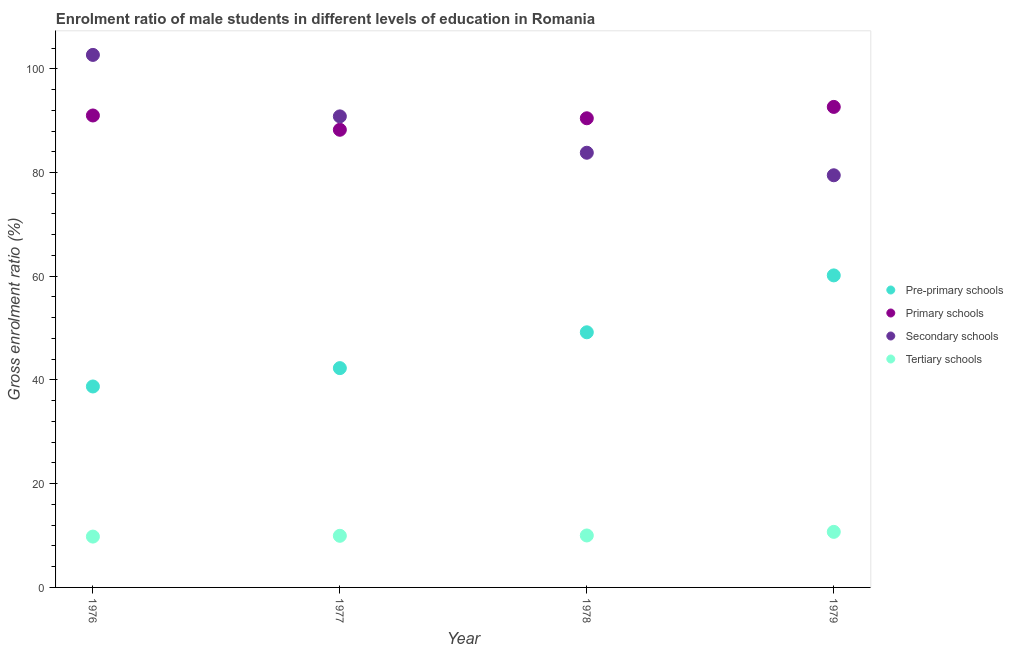How many different coloured dotlines are there?
Give a very brief answer. 4. Is the number of dotlines equal to the number of legend labels?
Provide a succinct answer. Yes. What is the gross enrolment ratio(female) in pre-primary schools in 1979?
Offer a terse response. 60.16. Across all years, what is the maximum gross enrolment ratio(female) in pre-primary schools?
Offer a terse response. 60.16. Across all years, what is the minimum gross enrolment ratio(female) in pre-primary schools?
Give a very brief answer. 38.74. In which year was the gross enrolment ratio(female) in tertiary schools maximum?
Provide a short and direct response. 1979. In which year was the gross enrolment ratio(female) in tertiary schools minimum?
Your response must be concise. 1976. What is the total gross enrolment ratio(female) in tertiary schools in the graph?
Keep it short and to the point. 40.49. What is the difference between the gross enrolment ratio(female) in tertiary schools in 1976 and that in 1978?
Provide a succinct answer. -0.22. What is the difference between the gross enrolment ratio(female) in primary schools in 1979 and the gross enrolment ratio(female) in tertiary schools in 1978?
Keep it short and to the point. 82.63. What is the average gross enrolment ratio(female) in pre-primary schools per year?
Your answer should be very brief. 47.6. In the year 1978, what is the difference between the gross enrolment ratio(female) in secondary schools and gross enrolment ratio(female) in primary schools?
Keep it short and to the point. -6.64. What is the ratio of the gross enrolment ratio(female) in secondary schools in 1978 to that in 1979?
Ensure brevity in your answer.  1.05. Is the gross enrolment ratio(female) in tertiary schools in 1977 less than that in 1978?
Keep it short and to the point. Yes. Is the difference between the gross enrolment ratio(female) in secondary schools in 1976 and 1977 greater than the difference between the gross enrolment ratio(female) in tertiary schools in 1976 and 1977?
Provide a succinct answer. Yes. What is the difference between the highest and the second highest gross enrolment ratio(female) in primary schools?
Make the answer very short. 1.65. What is the difference between the highest and the lowest gross enrolment ratio(female) in secondary schools?
Your answer should be very brief. 23.21. In how many years, is the gross enrolment ratio(female) in primary schools greater than the average gross enrolment ratio(female) in primary schools taken over all years?
Your response must be concise. 2. Is it the case that in every year, the sum of the gross enrolment ratio(female) in pre-primary schools and gross enrolment ratio(female) in primary schools is greater than the sum of gross enrolment ratio(female) in tertiary schools and gross enrolment ratio(female) in secondary schools?
Provide a succinct answer. Yes. Does the gross enrolment ratio(female) in pre-primary schools monotonically increase over the years?
Give a very brief answer. Yes. Is the gross enrolment ratio(female) in secondary schools strictly greater than the gross enrolment ratio(female) in tertiary schools over the years?
Your response must be concise. Yes. Is the gross enrolment ratio(female) in tertiary schools strictly less than the gross enrolment ratio(female) in primary schools over the years?
Your response must be concise. Yes. How many dotlines are there?
Your answer should be compact. 4. Does the graph contain any zero values?
Your answer should be very brief. No. Does the graph contain grids?
Offer a very short reply. No. Where does the legend appear in the graph?
Offer a terse response. Center right. How many legend labels are there?
Provide a succinct answer. 4. How are the legend labels stacked?
Your answer should be very brief. Vertical. What is the title of the graph?
Keep it short and to the point. Enrolment ratio of male students in different levels of education in Romania. Does "Fourth 20% of population" appear as one of the legend labels in the graph?
Your answer should be very brief. No. What is the label or title of the Y-axis?
Keep it short and to the point. Gross enrolment ratio (%). What is the Gross enrolment ratio (%) of Pre-primary schools in 1976?
Provide a succinct answer. 38.74. What is the Gross enrolment ratio (%) in Primary schools in 1976?
Make the answer very short. 91. What is the Gross enrolment ratio (%) in Secondary schools in 1976?
Your answer should be very brief. 102.67. What is the Gross enrolment ratio (%) in Tertiary schools in 1976?
Provide a short and direct response. 9.8. What is the Gross enrolment ratio (%) of Pre-primary schools in 1977?
Offer a very short reply. 42.28. What is the Gross enrolment ratio (%) of Primary schools in 1977?
Give a very brief answer. 88.24. What is the Gross enrolment ratio (%) of Secondary schools in 1977?
Give a very brief answer. 90.82. What is the Gross enrolment ratio (%) in Tertiary schools in 1977?
Your answer should be compact. 9.95. What is the Gross enrolment ratio (%) of Pre-primary schools in 1978?
Make the answer very short. 49.19. What is the Gross enrolment ratio (%) in Primary schools in 1978?
Your answer should be very brief. 90.46. What is the Gross enrolment ratio (%) of Secondary schools in 1978?
Your answer should be compact. 83.81. What is the Gross enrolment ratio (%) in Tertiary schools in 1978?
Offer a terse response. 10.02. What is the Gross enrolment ratio (%) of Pre-primary schools in 1979?
Your answer should be compact. 60.16. What is the Gross enrolment ratio (%) in Primary schools in 1979?
Your response must be concise. 92.65. What is the Gross enrolment ratio (%) in Secondary schools in 1979?
Your answer should be very brief. 79.47. What is the Gross enrolment ratio (%) of Tertiary schools in 1979?
Provide a succinct answer. 10.71. Across all years, what is the maximum Gross enrolment ratio (%) in Pre-primary schools?
Offer a very short reply. 60.16. Across all years, what is the maximum Gross enrolment ratio (%) in Primary schools?
Your response must be concise. 92.65. Across all years, what is the maximum Gross enrolment ratio (%) in Secondary schools?
Your answer should be compact. 102.67. Across all years, what is the maximum Gross enrolment ratio (%) in Tertiary schools?
Provide a succinct answer. 10.71. Across all years, what is the minimum Gross enrolment ratio (%) of Pre-primary schools?
Your response must be concise. 38.74. Across all years, what is the minimum Gross enrolment ratio (%) of Primary schools?
Keep it short and to the point. 88.24. Across all years, what is the minimum Gross enrolment ratio (%) in Secondary schools?
Your answer should be compact. 79.47. Across all years, what is the minimum Gross enrolment ratio (%) of Tertiary schools?
Provide a short and direct response. 9.8. What is the total Gross enrolment ratio (%) of Pre-primary schools in the graph?
Offer a very short reply. 190.38. What is the total Gross enrolment ratio (%) of Primary schools in the graph?
Your response must be concise. 362.34. What is the total Gross enrolment ratio (%) in Secondary schools in the graph?
Provide a succinct answer. 356.78. What is the total Gross enrolment ratio (%) of Tertiary schools in the graph?
Give a very brief answer. 40.49. What is the difference between the Gross enrolment ratio (%) in Pre-primary schools in 1976 and that in 1977?
Provide a succinct answer. -3.54. What is the difference between the Gross enrolment ratio (%) of Primary schools in 1976 and that in 1977?
Make the answer very short. 2.76. What is the difference between the Gross enrolment ratio (%) in Secondary schools in 1976 and that in 1977?
Make the answer very short. 11.85. What is the difference between the Gross enrolment ratio (%) in Tertiary schools in 1976 and that in 1977?
Your answer should be compact. -0.15. What is the difference between the Gross enrolment ratio (%) of Pre-primary schools in 1976 and that in 1978?
Offer a very short reply. -10.45. What is the difference between the Gross enrolment ratio (%) in Primary schools in 1976 and that in 1978?
Give a very brief answer. 0.54. What is the difference between the Gross enrolment ratio (%) of Secondary schools in 1976 and that in 1978?
Give a very brief answer. 18.86. What is the difference between the Gross enrolment ratio (%) of Tertiary schools in 1976 and that in 1978?
Make the answer very short. -0.22. What is the difference between the Gross enrolment ratio (%) of Pre-primary schools in 1976 and that in 1979?
Your answer should be very brief. -21.42. What is the difference between the Gross enrolment ratio (%) of Primary schools in 1976 and that in 1979?
Ensure brevity in your answer.  -1.65. What is the difference between the Gross enrolment ratio (%) in Secondary schools in 1976 and that in 1979?
Ensure brevity in your answer.  23.21. What is the difference between the Gross enrolment ratio (%) in Tertiary schools in 1976 and that in 1979?
Ensure brevity in your answer.  -0.91. What is the difference between the Gross enrolment ratio (%) of Pre-primary schools in 1977 and that in 1978?
Make the answer very short. -6.91. What is the difference between the Gross enrolment ratio (%) in Primary schools in 1977 and that in 1978?
Your answer should be very brief. -2.22. What is the difference between the Gross enrolment ratio (%) of Secondary schools in 1977 and that in 1978?
Make the answer very short. 7.01. What is the difference between the Gross enrolment ratio (%) of Tertiary schools in 1977 and that in 1978?
Your answer should be very brief. -0.06. What is the difference between the Gross enrolment ratio (%) in Pre-primary schools in 1977 and that in 1979?
Your answer should be very brief. -17.88. What is the difference between the Gross enrolment ratio (%) in Primary schools in 1977 and that in 1979?
Offer a terse response. -4.41. What is the difference between the Gross enrolment ratio (%) in Secondary schools in 1977 and that in 1979?
Provide a succinct answer. 11.36. What is the difference between the Gross enrolment ratio (%) in Tertiary schools in 1977 and that in 1979?
Your answer should be compact. -0.76. What is the difference between the Gross enrolment ratio (%) of Pre-primary schools in 1978 and that in 1979?
Offer a terse response. -10.97. What is the difference between the Gross enrolment ratio (%) in Primary schools in 1978 and that in 1979?
Ensure brevity in your answer.  -2.19. What is the difference between the Gross enrolment ratio (%) in Secondary schools in 1978 and that in 1979?
Your answer should be compact. 4.35. What is the difference between the Gross enrolment ratio (%) in Tertiary schools in 1978 and that in 1979?
Ensure brevity in your answer.  -0.7. What is the difference between the Gross enrolment ratio (%) of Pre-primary schools in 1976 and the Gross enrolment ratio (%) of Primary schools in 1977?
Offer a very short reply. -49.5. What is the difference between the Gross enrolment ratio (%) in Pre-primary schools in 1976 and the Gross enrolment ratio (%) in Secondary schools in 1977?
Offer a terse response. -52.08. What is the difference between the Gross enrolment ratio (%) of Pre-primary schools in 1976 and the Gross enrolment ratio (%) of Tertiary schools in 1977?
Ensure brevity in your answer.  28.79. What is the difference between the Gross enrolment ratio (%) in Primary schools in 1976 and the Gross enrolment ratio (%) in Secondary schools in 1977?
Your response must be concise. 0.17. What is the difference between the Gross enrolment ratio (%) in Primary schools in 1976 and the Gross enrolment ratio (%) in Tertiary schools in 1977?
Provide a succinct answer. 81.04. What is the difference between the Gross enrolment ratio (%) in Secondary schools in 1976 and the Gross enrolment ratio (%) in Tertiary schools in 1977?
Offer a very short reply. 92.72. What is the difference between the Gross enrolment ratio (%) in Pre-primary schools in 1976 and the Gross enrolment ratio (%) in Primary schools in 1978?
Keep it short and to the point. -51.71. What is the difference between the Gross enrolment ratio (%) in Pre-primary schools in 1976 and the Gross enrolment ratio (%) in Secondary schools in 1978?
Keep it short and to the point. -45.07. What is the difference between the Gross enrolment ratio (%) in Pre-primary schools in 1976 and the Gross enrolment ratio (%) in Tertiary schools in 1978?
Provide a succinct answer. 28.73. What is the difference between the Gross enrolment ratio (%) in Primary schools in 1976 and the Gross enrolment ratio (%) in Secondary schools in 1978?
Offer a very short reply. 7.18. What is the difference between the Gross enrolment ratio (%) of Primary schools in 1976 and the Gross enrolment ratio (%) of Tertiary schools in 1978?
Provide a succinct answer. 80.98. What is the difference between the Gross enrolment ratio (%) in Secondary schools in 1976 and the Gross enrolment ratio (%) in Tertiary schools in 1978?
Provide a short and direct response. 92.66. What is the difference between the Gross enrolment ratio (%) in Pre-primary schools in 1976 and the Gross enrolment ratio (%) in Primary schools in 1979?
Offer a very short reply. -53.9. What is the difference between the Gross enrolment ratio (%) in Pre-primary schools in 1976 and the Gross enrolment ratio (%) in Secondary schools in 1979?
Your answer should be compact. -40.72. What is the difference between the Gross enrolment ratio (%) of Pre-primary schools in 1976 and the Gross enrolment ratio (%) of Tertiary schools in 1979?
Keep it short and to the point. 28.03. What is the difference between the Gross enrolment ratio (%) in Primary schools in 1976 and the Gross enrolment ratio (%) in Secondary schools in 1979?
Offer a terse response. 11.53. What is the difference between the Gross enrolment ratio (%) in Primary schools in 1976 and the Gross enrolment ratio (%) in Tertiary schools in 1979?
Offer a terse response. 80.28. What is the difference between the Gross enrolment ratio (%) in Secondary schools in 1976 and the Gross enrolment ratio (%) in Tertiary schools in 1979?
Provide a short and direct response. 91.96. What is the difference between the Gross enrolment ratio (%) in Pre-primary schools in 1977 and the Gross enrolment ratio (%) in Primary schools in 1978?
Your answer should be very brief. -48.17. What is the difference between the Gross enrolment ratio (%) in Pre-primary schools in 1977 and the Gross enrolment ratio (%) in Secondary schools in 1978?
Offer a very short reply. -41.53. What is the difference between the Gross enrolment ratio (%) in Pre-primary schools in 1977 and the Gross enrolment ratio (%) in Tertiary schools in 1978?
Your answer should be compact. 32.27. What is the difference between the Gross enrolment ratio (%) of Primary schools in 1977 and the Gross enrolment ratio (%) of Secondary schools in 1978?
Provide a short and direct response. 4.43. What is the difference between the Gross enrolment ratio (%) in Primary schools in 1977 and the Gross enrolment ratio (%) in Tertiary schools in 1978?
Make the answer very short. 78.22. What is the difference between the Gross enrolment ratio (%) of Secondary schools in 1977 and the Gross enrolment ratio (%) of Tertiary schools in 1978?
Your response must be concise. 80.81. What is the difference between the Gross enrolment ratio (%) of Pre-primary schools in 1977 and the Gross enrolment ratio (%) of Primary schools in 1979?
Ensure brevity in your answer.  -50.36. What is the difference between the Gross enrolment ratio (%) in Pre-primary schools in 1977 and the Gross enrolment ratio (%) in Secondary schools in 1979?
Provide a succinct answer. -37.18. What is the difference between the Gross enrolment ratio (%) in Pre-primary schools in 1977 and the Gross enrolment ratio (%) in Tertiary schools in 1979?
Give a very brief answer. 31.57. What is the difference between the Gross enrolment ratio (%) in Primary schools in 1977 and the Gross enrolment ratio (%) in Secondary schools in 1979?
Your response must be concise. 8.77. What is the difference between the Gross enrolment ratio (%) of Primary schools in 1977 and the Gross enrolment ratio (%) of Tertiary schools in 1979?
Provide a succinct answer. 77.53. What is the difference between the Gross enrolment ratio (%) of Secondary schools in 1977 and the Gross enrolment ratio (%) of Tertiary schools in 1979?
Offer a terse response. 80.11. What is the difference between the Gross enrolment ratio (%) in Pre-primary schools in 1978 and the Gross enrolment ratio (%) in Primary schools in 1979?
Offer a terse response. -43.46. What is the difference between the Gross enrolment ratio (%) of Pre-primary schools in 1978 and the Gross enrolment ratio (%) of Secondary schools in 1979?
Your answer should be very brief. -30.27. What is the difference between the Gross enrolment ratio (%) in Pre-primary schools in 1978 and the Gross enrolment ratio (%) in Tertiary schools in 1979?
Provide a short and direct response. 38.48. What is the difference between the Gross enrolment ratio (%) of Primary schools in 1978 and the Gross enrolment ratio (%) of Secondary schools in 1979?
Provide a short and direct response. 10.99. What is the difference between the Gross enrolment ratio (%) of Primary schools in 1978 and the Gross enrolment ratio (%) of Tertiary schools in 1979?
Offer a very short reply. 79.74. What is the difference between the Gross enrolment ratio (%) in Secondary schools in 1978 and the Gross enrolment ratio (%) in Tertiary schools in 1979?
Give a very brief answer. 73.1. What is the average Gross enrolment ratio (%) in Pre-primary schools per year?
Keep it short and to the point. 47.6. What is the average Gross enrolment ratio (%) of Primary schools per year?
Your answer should be very brief. 90.58. What is the average Gross enrolment ratio (%) in Secondary schools per year?
Your answer should be very brief. 89.19. What is the average Gross enrolment ratio (%) of Tertiary schools per year?
Offer a very short reply. 10.12. In the year 1976, what is the difference between the Gross enrolment ratio (%) of Pre-primary schools and Gross enrolment ratio (%) of Primary schools?
Provide a short and direct response. -52.25. In the year 1976, what is the difference between the Gross enrolment ratio (%) of Pre-primary schools and Gross enrolment ratio (%) of Secondary schools?
Offer a terse response. -63.93. In the year 1976, what is the difference between the Gross enrolment ratio (%) of Pre-primary schools and Gross enrolment ratio (%) of Tertiary schools?
Offer a terse response. 28.94. In the year 1976, what is the difference between the Gross enrolment ratio (%) in Primary schools and Gross enrolment ratio (%) in Secondary schools?
Make the answer very short. -11.68. In the year 1976, what is the difference between the Gross enrolment ratio (%) of Primary schools and Gross enrolment ratio (%) of Tertiary schools?
Offer a terse response. 81.19. In the year 1976, what is the difference between the Gross enrolment ratio (%) of Secondary schools and Gross enrolment ratio (%) of Tertiary schools?
Keep it short and to the point. 92.87. In the year 1977, what is the difference between the Gross enrolment ratio (%) in Pre-primary schools and Gross enrolment ratio (%) in Primary schools?
Keep it short and to the point. -45.96. In the year 1977, what is the difference between the Gross enrolment ratio (%) in Pre-primary schools and Gross enrolment ratio (%) in Secondary schools?
Ensure brevity in your answer.  -48.54. In the year 1977, what is the difference between the Gross enrolment ratio (%) in Pre-primary schools and Gross enrolment ratio (%) in Tertiary schools?
Offer a terse response. 32.33. In the year 1977, what is the difference between the Gross enrolment ratio (%) in Primary schools and Gross enrolment ratio (%) in Secondary schools?
Your response must be concise. -2.58. In the year 1977, what is the difference between the Gross enrolment ratio (%) of Primary schools and Gross enrolment ratio (%) of Tertiary schools?
Your answer should be very brief. 78.29. In the year 1977, what is the difference between the Gross enrolment ratio (%) in Secondary schools and Gross enrolment ratio (%) in Tertiary schools?
Ensure brevity in your answer.  80.87. In the year 1978, what is the difference between the Gross enrolment ratio (%) of Pre-primary schools and Gross enrolment ratio (%) of Primary schools?
Your answer should be very brief. -41.26. In the year 1978, what is the difference between the Gross enrolment ratio (%) of Pre-primary schools and Gross enrolment ratio (%) of Secondary schools?
Offer a very short reply. -34.62. In the year 1978, what is the difference between the Gross enrolment ratio (%) in Pre-primary schools and Gross enrolment ratio (%) in Tertiary schools?
Your answer should be compact. 39.17. In the year 1978, what is the difference between the Gross enrolment ratio (%) of Primary schools and Gross enrolment ratio (%) of Secondary schools?
Your answer should be compact. 6.64. In the year 1978, what is the difference between the Gross enrolment ratio (%) in Primary schools and Gross enrolment ratio (%) in Tertiary schools?
Your response must be concise. 80.44. In the year 1978, what is the difference between the Gross enrolment ratio (%) of Secondary schools and Gross enrolment ratio (%) of Tertiary schools?
Offer a terse response. 73.79. In the year 1979, what is the difference between the Gross enrolment ratio (%) in Pre-primary schools and Gross enrolment ratio (%) in Primary schools?
Ensure brevity in your answer.  -32.49. In the year 1979, what is the difference between the Gross enrolment ratio (%) of Pre-primary schools and Gross enrolment ratio (%) of Secondary schools?
Offer a very short reply. -19.3. In the year 1979, what is the difference between the Gross enrolment ratio (%) of Pre-primary schools and Gross enrolment ratio (%) of Tertiary schools?
Provide a short and direct response. 49.45. In the year 1979, what is the difference between the Gross enrolment ratio (%) of Primary schools and Gross enrolment ratio (%) of Secondary schools?
Provide a succinct answer. 13.18. In the year 1979, what is the difference between the Gross enrolment ratio (%) of Primary schools and Gross enrolment ratio (%) of Tertiary schools?
Offer a very short reply. 81.94. In the year 1979, what is the difference between the Gross enrolment ratio (%) in Secondary schools and Gross enrolment ratio (%) in Tertiary schools?
Offer a terse response. 68.75. What is the ratio of the Gross enrolment ratio (%) of Pre-primary schools in 1976 to that in 1977?
Offer a terse response. 0.92. What is the ratio of the Gross enrolment ratio (%) in Primary schools in 1976 to that in 1977?
Keep it short and to the point. 1.03. What is the ratio of the Gross enrolment ratio (%) of Secondary schools in 1976 to that in 1977?
Your answer should be very brief. 1.13. What is the ratio of the Gross enrolment ratio (%) in Tertiary schools in 1976 to that in 1977?
Your response must be concise. 0.98. What is the ratio of the Gross enrolment ratio (%) in Pre-primary schools in 1976 to that in 1978?
Provide a short and direct response. 0.79. What is the ratio of the Gross enrolment ratio (%) in Secondary schools in 1976 to that in 1978?
Give a very brief answer. 1.23. What is the ratio of the Gross enrolment ratio (%) in Tertiary schools in 1976 to that in 1978?
Offer a very short reply. 0.98. What is the ratio of the Gross enrolment ratio (%) of Pre-primary schools in 1976 to that in 1979?
Your answer should be compact. 0.64. What is the ratio of the Gross enrolment ratio (%) of Primary schools in 1976 to that in 1979?
Give a very brief answer. 0.98. What is the ratio of the Gross enrolment ratio (%) in Secondary schools in 1976 to that in 1979?
Provide a succinct answer. 1.29. What is the ratio of the Gross enrolment ratio (%) of Tertiary schools in 1976 to that in 1979?
Your response must be concise. 0.92. What is the ratio of the Gross enrolment ratio (%) of Pre-primary schools in 1977 to that in 1978?
Provide a succinct answer. 0.86. What is the ratio of the Gross enrolment ratio (%) in Primary schools in 1977 to that in 1978?
Offer a very short reply. 0.98. What is the ratio of the Gross enrolment ratio (%) of Secondary schools in 1977 to that in 1978?
Your response must be concise. 1.08. What is the ratio of the Gross enrolment ratio (%) in Pre-primary schools in 1977 to that in 1979?
Make the answer very short. 0.7. What is the ratio of the Gross enrolment ratio (%) in Tertiary schools in 1977 to that in 1979?
Your response must be concise. 0.93. What is the ratio of the Gross enrolment ratio (%) of Pre-primary schools in 1978 to that in 1979?
Your response must be concise. 0.82. What is the ratio of the Gross enrolment ratio (%) in Primary schools in 1978 to that in 1979?
Provide a succinct answer. 0.98. What is the ratio of the Gross enrolment ratio (%) in Secondary schools in 1978 to that in 1979?
Your answer should be compact. 1.05. What is the ratio of the Gross enrolment ratio (%) in Tertiary schools in 1978 to that in 1979?
Your response must be concise. 0.94. What is the difference between the highest and the second highest Gross enrolment ratio (%) in Pre-primary schools?
Your answer should be very brief. 10.97. What is the difference between the highest and the second highest Gross enrolment ratio (%) of Primary schools?
Ensure brevity in your answer.  1.65. What is the difference between the highest and the second highest Gross enrolment ratio (%) of Secondary schools?
Offer a very short reply. 11.85. What is the difference between the highest and the second highest Gross enrolment ratio (%) in Tertiary schools?
Your answer should be compact. 0.7. What is the difference between the highest and the lowest Gross enrolment ratio (%) in Pre-primary schools?
Make the answer very short. 21.42. What is the difference between the highest and the lowest Gross enrolment ratio (%) in Primary schools?
Keep it short and to the point. 4.41. What is the difference between the highest and the lowest Gross enrolment ratio (%) in Secondary schools?
Your answer should be compact. 23.21. What is the difference between the highest and the lowest Gross enrolment ratio (%) of Tertiary schools?
Make the answer very short. 0.91. 